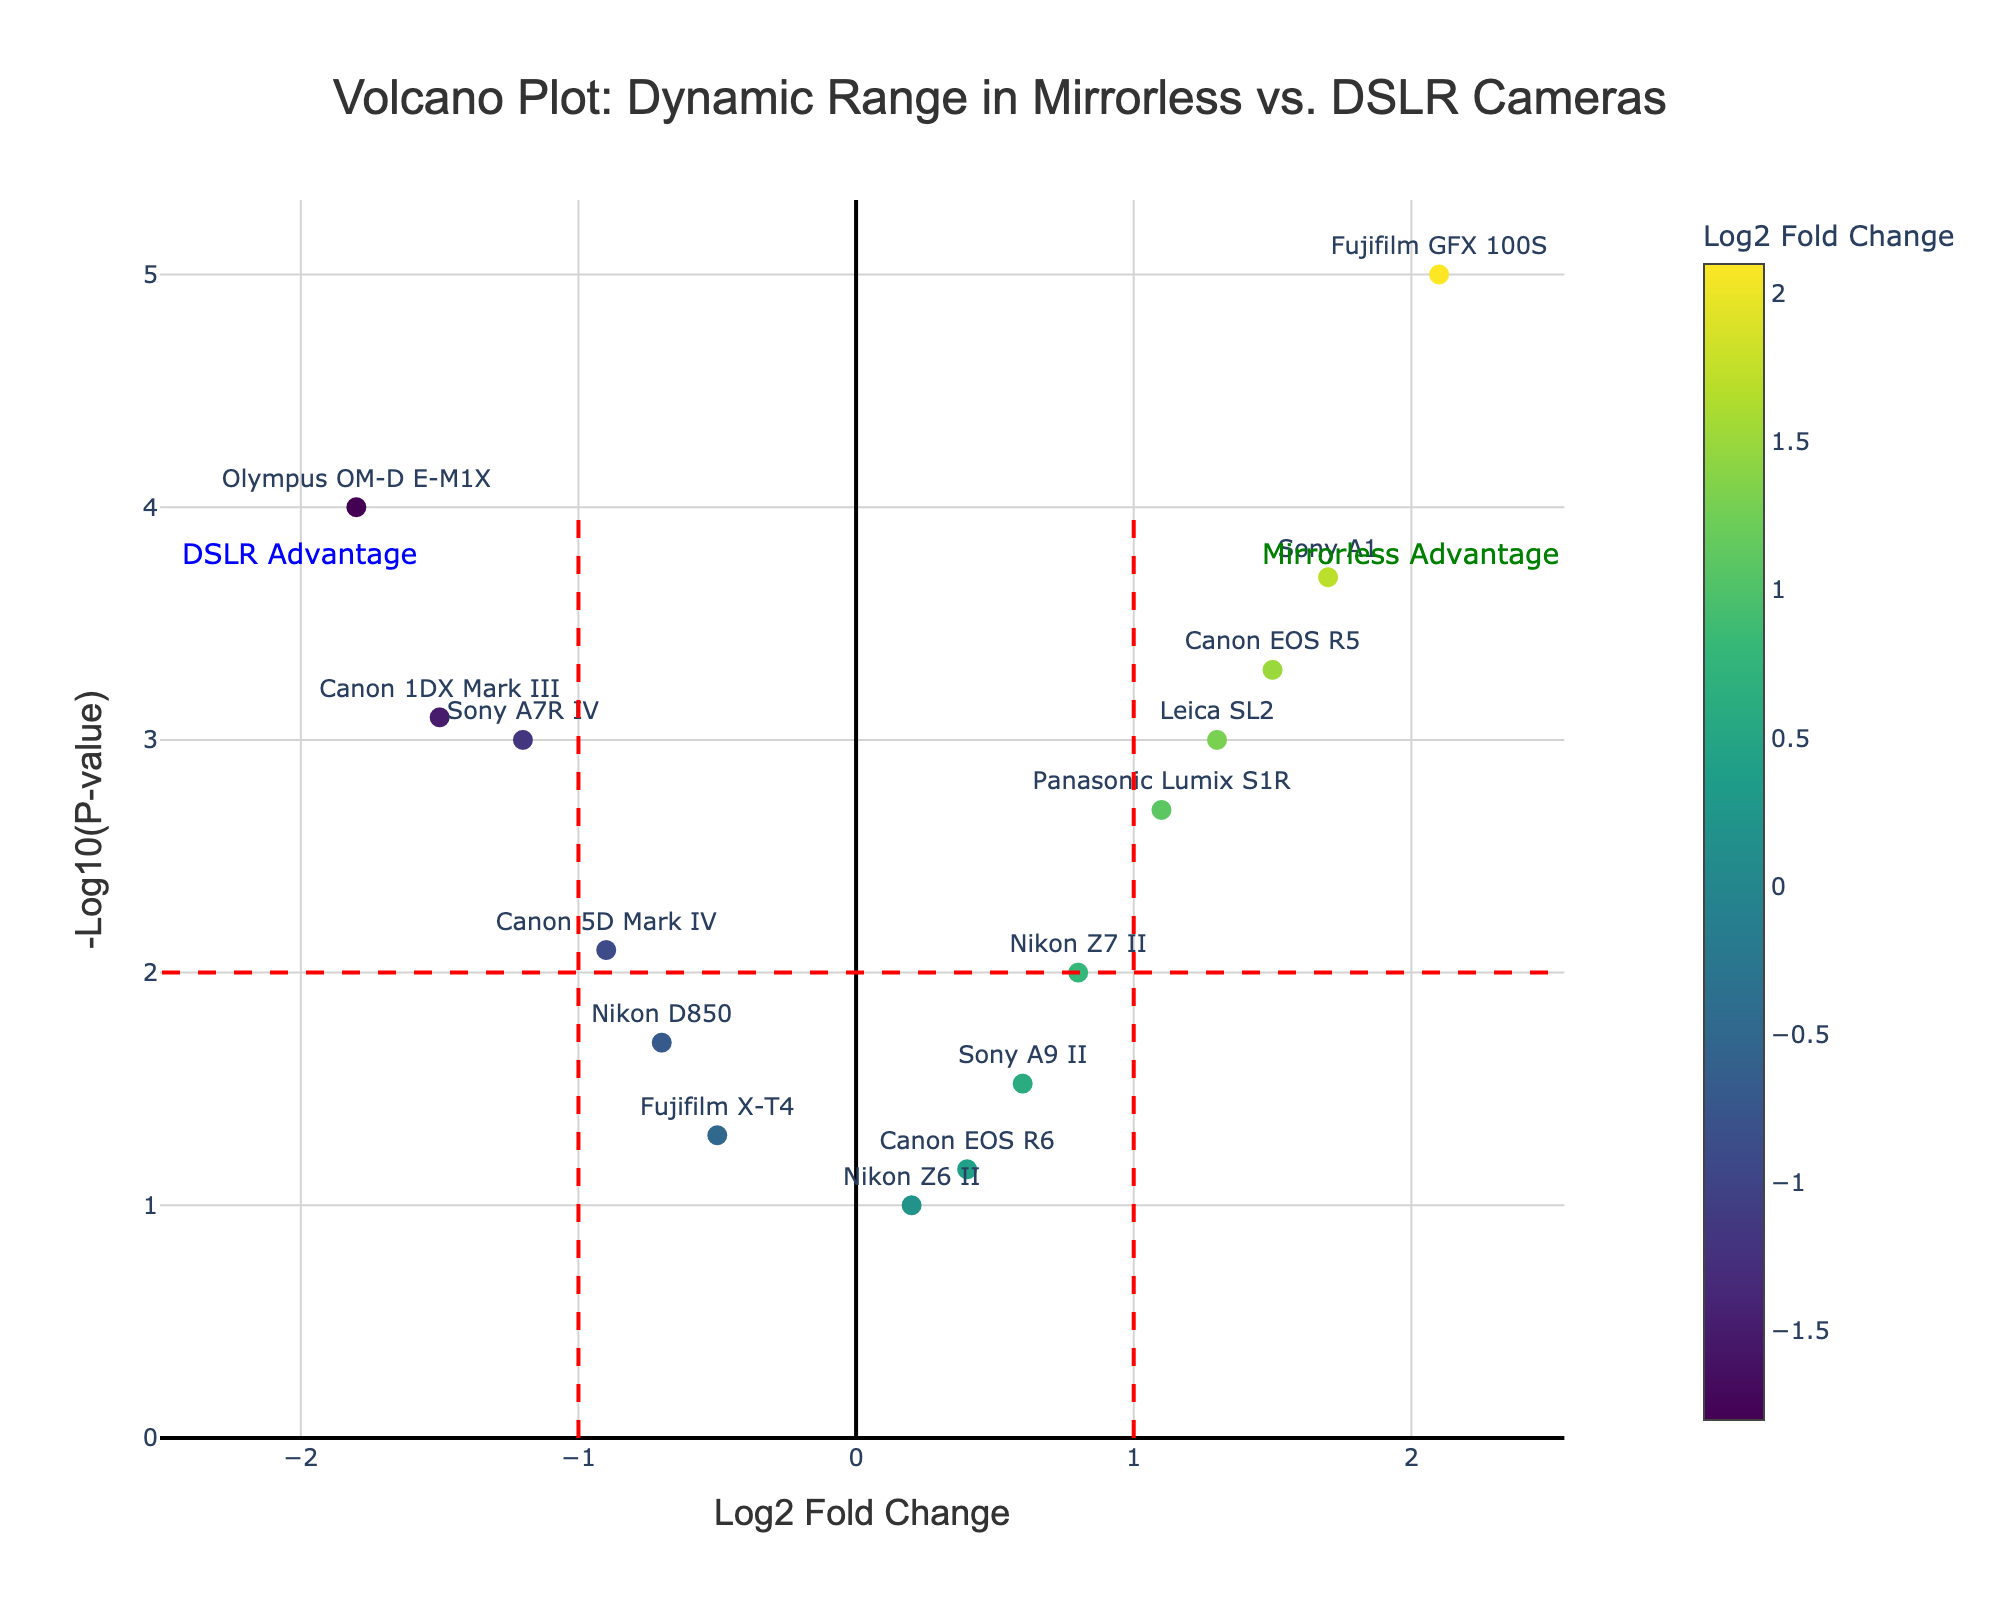What's the title of the plot? The title of the plot is clearly written at the top, centered, in a larger font. It reads: 'Volcano Plot: Dynamic Range in Mirrorless vs. DSLR Cameras'
Answer: 'Volcano Plot: Dynamic Range in Mirrorless vs. DSLR Cameras' What does the x-axis represent? The x-axis represents 'Log2 Fold Change,' which measures the change in dynamic range between camera models. This is clearly denoted by the label at the bottom of the axis.
Answer: Log2 Fold Change What does the y-axis represent? The y-axis represents '-Log10(P-value),' which indicates the statistical significance of the dynamic range differences between camera models. This is indicated by the label along the y-axis in the plot.
Answer: -Log10(P-value) How many camera models are represented in the plot? There are 15 camera models represented in the plot, each marked by a unique point. We can count the number of labeled points on the plot.
Answer: 15 Which camera model has the highest -Log10(P-value)? To determine this, we look for the point that is highest on the y-axis. The 'Fujifilm GFX 100S' has the highest -Log10(P-value) because it appears at the topmost point on the plot.
Answer: Fujifilm GFX 100S Which camera models are considered to have a "Mirrorless Advantage"? 'Mirrorless Advantage' is annotated on the top right of the plot. The points above the horizontal line (P-value < 0.01) and to the right of the vertical red line (Log2 Fold Change > 1) fall into this category. The models are 'Canon EOS R5,' 'Fujifilm GFX 100S,' 'Sony A1,' and 'Leica SL2'.
Answer: Canon EOS R5, Fujifilm GFX 100S, Sony A1, Leica SL2 How does the plot distinguish between cameras with positive and negative Log2 Fold Changes? The plot uses the horizontal placement (left or right of the vertical red lines at Log2 Fold Change = -1 and 1) and a color gradient (along a colorscale) to visually distinguish between positive and negative Log2 Fold Changes.
Answer: Horizontal placement and color gradient Which DSLR camera has the lowest Log2 Fold Change? We look for the point furthest to the left. The 'Olympus OM-D E-M1X' has the lowest Log2 Fold Change at -1.8, which is verified by locating its label on the far left of the plot.
Answer: Olympus OM-D E-M1X What is the range of the Log2 Fold Change values in this plot? The range is determined by the minimum and maximum values on the x-axis. The lowest Log2 Fold Change is -1.8 (Olympus OM-D E-M1X) and the highest is 2.1 (Fujifilm GFX 100S). Therefore, the range is 2.1 - (-1.8) = 3.9.
Answer: 3.9 